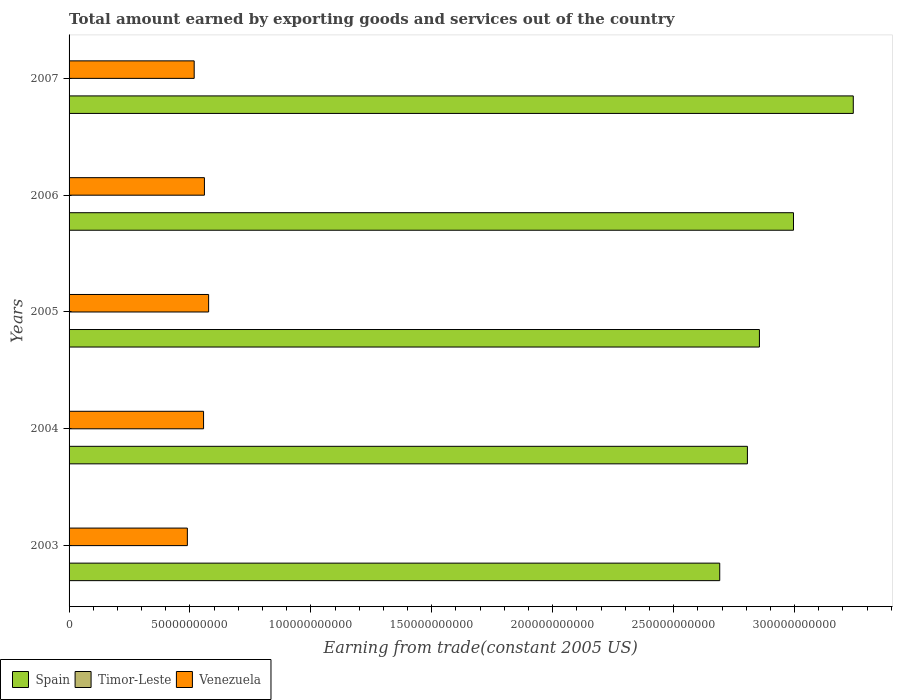How many different coloured bars are there?
Ensure brevity in your answer.  3. How many groups of bars are there?
Your response must be concise. 5. Are the number of bars per tick equal to the number of legend labels?
Provide a short and direct response. Yes. Are the number of bars on each tick of the Y-axis equal?
Your answer should be compact. Yes. How many bars are there on the 1st tick from the bottom?
Offer a terse response. 3. What is the label of the 4th group of bars from the top?
Provide a short and direct response. 2004. What is the total amount earned by exporting goods and services in Spain in 2005?
Give a very brief answer. 2.85e+11. Across all years, what is the maximum total amount earned by exporting goods and services in Venezuela?
Give a very brief answer. 5.77e+1. Across all years, what is the minimum total amount earned by exporting goods and services in Timor-Leste?
Provide a succinct answer. 4.00e+07. In which year was the total amount earned by exporting goods and services in Timor-Leste maximum?
Provide a short and direct response. 2007. In which year was the total amount earned by exporting goods and services in Timor-Leste minimum?
Give a very brief answer. 2005. What is the total total amount earned by exporting goods and services in Spain in the graph?
Offer a very short reply. 1.46e+12. What is the difference between the total amount earned by exporting goods and services in Spain in 2005 and that in 2007?
Offer a very short reply. -3.88e+1. What is the difference between the total amount earned by exporting goods and services in Timor-Leste in 2004 and the total amount earned by exporting goods and services in Venezuela in 2005?
Offer a terse response. -5.77e+1. What is the average total amount earned by exporting goods and services in Spain per year?
Offer a terse response. 2.92e+11. In the year 2007, what is the difference between the total amount earned by exporting goods and services in Venezuela and total amount earned by exporting goods and services in Spain?
Provide a succinct answer. -2.73e+11. What is the ratio of the total amount earned by exporting goods and services in Timor-Leste in 2005 to that in 2006?
Your answer should be compact. 0.98. What is the difference between the highest and the second highest total amount earned by exporting goods and services in Timor-Leste?
Offer a terse response. 1.00e+07. What is the difference between the highest and the lowest total amount earned by exporting goods and services in Venezuela?
Provide a short and direct response. 8.79e+09. In how many years, is the total amount earned by exporting goods and services in Timor-Leste greater than the average total amount earned by exporting goods and services in Timor-Leste taken over all years?
Your answer should be very brief. 1. What does the 2nd bar from the top in 2003 represents?
Ensure brevity in your answer.  Timor-Leste. How many bars are there?
Give a very brief answer. 15. Does the graph contain grids?
Offer a terse response. No. How many legend labels are there?
Make the answer very short. 3. What is the title of the graph?
Your answer should be very brief. Total amount earned by exporting goods and services out of the country. Does "Netherlands" appear as one of the legend labels in the graph?
Your answer should be very brief. No. What is the label or title of the X-axis?
Give a very brief answer. Earning from trade(constant 2005 US). What is the Earning from trade(constant 2005 US) of Spain in 2003?
Your answer should be compact. 2.69e+11. What is the Earning from trade(constant 2005 US) of Timor-Leste in 2003?
Keep it short and to the point. 4.33e+07. What is the Earning from trade(constant 2005 US) of Venezuela in 2003?
Provide a succinct answer. 4.89e+1. What is the Earning from trade(constant 2005 US) of Spain in 2004?
Your answer should be very brief. 2.81e+11. What is the Earning from trade(constant 2005 US) in Timor-Leste in 2004?
Make the answer very short. 4.25e+07. What is the Earning from trade(constant 2005 US) of Venezuela in 2004?
Make the answer very short. 5.56e+1. What is the Earning from trade(constant 2005 US) in Spain in 2005?
Give a very brief answer. 2.85e+11. What is the Earning from trade(constant 2005 US) in Timor-Leste in 2005?
Provide a succinct answer. 4.00e+07. What is the Earning from trade(constant 2005 US) of Venezuela in 2005?
Your answer should be compact. 5.77e+1. What is the Earning from trade(constant 2005 US) in Spain in 2006?
Offer a very short reply. 3.00e+11. What is the Earning from trade(constant 2005 US) in Timor-Leste in 2006?
Offer a very short reply. 4.08e+07. What is the Earning from trade(constant 2005 US) in Venezuela in 2006?
Provide a short and direct response. 5.60e+1. What is the Earning from trade(constant 2005 US) in Spain in 2007?
Offer a very short reply. 3.24e+11. What is the Earning from trade(constant 2005 US) of Timor-Leste in 2007?
Offer a terse response. 5.33e+07. What is the Earning from trade(constant 2005 US) of Venezuela in 2007?
Provide a succinct answer. 5.17e+1. Across all years, what is the maximum Earning from trade(constant 2005 US) of Spain?
Offer a terse response. 3.24e+11. Across all years, what is the maximum Earning from trade(constant 2005 US) of Timor-Leste?
Provide a succinct answer. 5.33e+07. Across all years, what is the maximum Earning from trade(constant 2005 US) in Venezuela?
Your answer should be compact. 5.77e+1. Across all years, what is the minimum Earning from trade(constant 2005 US) of Spain?
Your response must be concise. 2.69e+11. Across all years, what is the minimum Earning from trade(constant 2005 US) of Timor-Leste?
Offer a terse response. 4.00e+07. Across all years, what is the minimum Earning from trade(constant 2005 US) in Venezuela?
Offer a terse response. 4.89e+1. What is the total Earning from trade(constant 2005 US) in Spain in the graph?
Make the answer very short. 1.46e+12. What is the total Earning from trade(constant 2005 US) in Timor-Leste in the graph?
Ensure brevity in your answer.  2.20e+08. What is the total Earning from trade(constant 2005 US) of Venezuela in the graph?
Offer a very short reply. 2.70e+11. What is the difference between the Earning from trade(constant 2005 US) in Spain in 2003 and that in 2004?
Offer a terse response. -1.14e+1. What is the difference between the Earning from trade(constant 2005 US) of Timor-Leste in 2003 and that in 2004?
Make the answer very short. 8.33e+05. What is the difference between the Earning from trade(constant 2005 US) of Venezuela in 2003 and that in 2004?
Ensure brevity in your answer.  -6.69e+09. What is the difference between the Earning from trade(constant 2005 US) of Spain in 2003 and that in 2005?
Give a very brief answer. -1.64e+1. What is the difference between the Earning from trade(constant 2005 US) of Timor-Leste in 2003 and that in 2005?
Offer a terse response. 3.33e+06. What is the difference between the Earning from trade(constant 2005 US) of Venezuela in 2003 and that in 2005?
Your answer should be very brief. -8.79e+09. What is the difference between the Earning from trade(constant 2005 US) in Spain in 2003 and that in 2006?
Your answer should be very brief. -3.05e+1. What is the difference between the Earning from trade(constant 2005 US) in Timor-Leste in 2003 and that in 2006?
Your answer should be very brief. 2.50e+06. What is the difference between the Earning from trade(constant 2005 US) in Venezuela in 2003 and that in 2006?
Provide a succinct answer. -7.05e+09. What is the difference between the Earning from trade(constant 2005 US) in Spain in 2003 and that in 2007?
Your response must be concise. -5.52e+1. What is the difference between the Earning from trade(constant 2005 US) in Timor-Leste in 2003 and that in 2007?
Offer a terse response. -1.00e+07. What is the difference between the Earning from trade(constant 2005 US) in Venezuela in 2003 and that in 2007?
Your answer should be very brief. -2.82e+09. What is the difference between the Earning from trade(constant 2005 US) of Spain in 2004 and that in 2005?
Offer a very short reply. -4.97e+09. What is the difference between the Earning from trade(constant 2005 US) in Timor-Leste in 2004 and that in 2005?
Provide a short and direct response. 2.50e+06. What is the difference between the Earning from trade(constant 2005 US) of Venezuela in 2004 and that in 2005?
Provide a succinct answer. -2.10e+09. What is the difference between the Earning from trade(constant 2005 US) of Spain in 2004 and that in 2006?
Offer a very short reply. -1.91e+1. What is the difference between the Earning from trade(constant 2005 US) of Timor-Leste in 2004 and that in 2006?
Give a very brief answer. 1.67e+06. What is the difference between the Earning from trade(constant 2005 US) in Venezuela in 2004 and that in 2006?
Keep it short and to the point. -3.55e+08. What is the difference between the Earning from trade(constant 2005 US) in Spain in 2004 and that in 2007?
Provide a succinct answer. -4.38e+1. What is the difference between the Earning from trade(constant 2005 US) of Timor-Leste in 2004 and that in 2007?
Provide a succinct answer. -1.08e+07. What is the difference between the Earning from trade(constant 2005 US) in Venezuela in 2004 and that in 2007?
Provide a succinct answer. 3.87e+09. What is the difference between the Earning from trade(constant 2005 US) of Spain in 2005 and that in 2006?
Your answer should be very brief. -1.41e+1. What is the difference between the Earning from trade(constant 2005 US) of Timor-Leste in 2005 and that in 2006?
Your answer should be very brief. -8.33e+05. What is the difference between the Earning from trade(constant 2005 US) of Venezuela in 2005 and that in 2006?
Ensure brevity in your answer.  1.74e+09. What is the difference between the Earning from trade(constant 2005 US) in Spain in 2005 and that in 2007?
Provide a short and direct response. -3.88e+1. What is the difference between the Earning from trade(constant 2005 US) of Timor-Leste in 2005 and that in 2007?
Provide a short and direct response. -1.33e+07. What is the difference between the Earning from trade(constant 2005 US) in Venezuela in 2005 and that in 2007?
Offer a very short reply. 5.97e+09. What is the difference between the Earning from trade(constant 2005 US) of Spain in 2006 and that in 2007?
Offer a terse response. -2.47e+1. What is the difference between the Earning from trade(constant 2005 US) of Timor-Leste in 2006 and that in 2007?
Your answer should be very brief. -1.25e+07. What is the difference between the Earning from trade(constant 2005 US) in Venezuela in 2006 and that in 2007?
Provide a short and direct response. 4.23e+09. What is the difference between the Earning from trade(constant 2005 US) in Spain in 2003 and the Earning from trade(constant 2005 US) in Timor-Leste in 2004?
Offer a very short reply. 2.69e+11. What is the difference between the Earning from trade(constant 2005 US) in Spain in 2003 and the Earning from trade(constant 2005 US) in Venezuela in 2004?
Provide a succinct answer. 2.13e+11. What is the difference between the Earning from trade(constant 2005 US) of Timor-Leste in 2003 and the Earning from trade(constant 2005 US) of Venezuela in 2004?
Provide a succinct answer. -5.56e+1. What is the difference between the Earning from trade(constant 2005 US) of Spain in 2003 and the Earning from trade(constant 2005 US) of Timor-Leste in 2005?
Your response must be concise. 2.69e+11. What is the difference between the Earning from trade(constant 2005 US) of Spain in 2003 and the Earning from trade(constant 2005 US) of Venezuela in 2005?
Ensure brevity in your answer.  2.11e+11. What is the difference between the Earning from trade(constant 2005 US) in Timor-Leste in 2003 and the Earning from trade(constant 2005 US) in Venezuela in 2005?
Offer a terse response. -5.77e+1. What is the difference between the Earning from trade(constant 2005 US) of Spain in 2003 and the Earning from trade(constant 2005 US) of Timor-Leste in 2006?
Provide a succinct answer. 2.69e+11. What is the difference between the Earning from trade(constant 2005 US) of Spain in 2003 and the Earning from trade(constant 2005 US) of Venezuela in 2006?
Provide a short and direct response. 2.13e+11. What is the difference between the Earning from trade(constant 2005 US) of Timor-Leste in 2003 and the Earning from trade(constant 2005 US) of Venezuela in 2006?
Your response must be concise. -5.59e+1. What is the difference between the Earning from trade(constant 2005 US) in Spain in 2003 and the Earning from trade(constant 2005 US) in Timor-Leste in 2007?
Your answer should be compact. 2.69e+11. What is the difference between the Earning from trade(constant 2005 US) in Spain in 2003 and the Earning from trade(constant 2005 US) in Venezuela in 2007?
Offer a terse response. 2.17e+11. What is the difference between the Earning from trade(constant 2005 US) in Timor-Leste in 2003 and the Earning from trade(constant 2005 US) in Venezuela in 2007?
Your answer should be very brief. -5.17e+1. What is the difference between the Earning from trade(constant 2005 US) in Spain in 2004 and the Earning from trade(constant 2005 US) in Timor-Leste in 2005?
Offer a very short reply. 2.80e+11. What is the difference between the Earning from trade(constant 2005 US) of Spain in 2004 and the Earning from trade(constant 2005 US) of Venezuela in 2005?
Your response must be concise. 2.23e+11. What is the difference between the Earning from trade(constant 2005 US) in Timor-Leste in 2004 and the Earning from trade(constant 2005 US) in Venezuela in 2005?
Provide a short and direct response. -5.77e+1. What is the difference between the Earning from trade(constant 2005 US) in Spain in 2004 and the Earning from trade(constant 2005 US) in Timor-Leste in 2006?
Give a very brief answer. 2.80e+11. What is the difference between the Earning from trade(constant 2005 US) in Spain in 2004 and the Earning from trade(constant 2005 US) in Venezuela in 2006?
Your response must be concise. 2.25e+11. What is the difference between the Earning from trade(constant 2005 US) in Timor-Leste in 2004 and the Earning from trade(constant 2005 US) in Venezuela in 2006?
Provide a short and direct response. -5.59e+1. What is the difference between the Earning from trade(constant 2005 US) in Spain in 2004 and the Earning from trade(constant 2005 US) in Timor-Leste in 2007?
Make the answer very short. 2.80e+11. What is the difference between the Earning from trade(constant 2005 US) of Spain in 2004 and the Earning from trade(constant 2005 US) of Venezuela in 2007?
Offer a terse response. 2.29e+11. What is the difference between the Earning from trade(constant 2005 US) of Timor-Leste in 2004 and the Earning from trade(constant 2005 US) of Venezuela in 2007?
Your answer should be very brief. -5.17e+1. What is the difference between the Earning from trade(constant 2005 US) in Spain in 2005 and the Earning from trade(constant 2005 US) in Timor-Leste in 2006?
Make the answer very short. 2.85e+11. What is the difference between the Earning from trade(constant 2005 US) of Spain in 2005 and the Earning from trade(constant 2005 US) of Venezuela in 2006?
Keep it short and to the point. 2.30e+11. What is the difference between the Earning from trade(constant 2005 US) in Timor-Leste in 2005 and the Earning from trade(constant 2005 US) in Venezuela in 2006?
Your answer should be very brief. -5.59e+1. What is the difference between the Earning from trade(constant 2005 US) in Spain in 2005 and the Earning from trade(constant 2005 US) in Timor-Leste in 2007?
Ensure brevity in your answer.  2.85e+11. What is the difference between the Earning from trade(constant 2005 US) of Spain in 2005 and the Earning from trade(constant 2005 US) of Venezuela in 2007?
Offer a terse response. 2.34e+11. What is the difference between the Earning from trade(constant 2005 US) in Timor-Leste in 2005 and the Earning from trade(constant 2005 US) in Venezuela in 2007?
Give a very brief answer. -5.17e+1. What is the difference between the Earning from trade(constant 2005 US) of Spain in 2006 and the Earning from trade(constant 2005 US) of Timor-Leste in 2007?
Offer a very short reply. 3.00e+11. What is the difference between the Earning from trade(constant 2005 US) of Spain in 2006 and the Earning from trade(constant 2005 US) of Venezuela in 2007?
Your answer should be compact. 2.48e+11. What is the difference between the Earning from trade(constant 2005 US) in Timor-Leste in 2006 and the Earning from trade(constant 2005 US) in Venezuela in 2007?
Ensure brevity in your answer.  -5.17e+1. What is the average Earning from trade(constant 2005 US) of Spain per year?
Your answer should be compact. 2.92e+11. What is the average Earning from trade(constant 2005 US) of Timor-Leste per year?
Provide a succinct answer. 4.40e+07. What is the average Earning from trade(constant 2005 US) in Venezuela per year?
Offer a terse response. 5.40e+1. In the year 2003, what is the difference between the Earning from trade(constant 2005 US) in Spain and Earning from trade(constant 2005 US) in Timor-Leste?
Keep it short and to the point. 2.69e+11. In the year 2003, what is the difference between the Earning from trade(constant 2005 US) of Spain and Earning from trade(constant 2005 US) of Venezuela?
Your answer should be very brief. 2.20e+11. In the year 2003, what is the difference between the Earning from trade(constant 2005 US) of Timor-Leste and Earning from trade(constant 2005 US) of Venezuela?
Offer a terse response. -4.89e+1. In the year 2004, what is the difference between the Earning from trade(constant 2005 US) in Spain and Earning from trade(constant 2005 US) in Timor-Leste?
Offer a very short reply. 2.80e+11. In the year 2004, what is the difference between the Earning from trade(constant 2005 US) in Spain and Earning from trade(constant 2005 US) in Venezuela?
Your answer should be compact. 2.25e+11. In the year 2004, what is the difference between the Earning from trade(constant 2005 US) in Timor-Leste and Earning from trade(constant 2005 US) in Venezuela?
Offer a very short reply. -5.56e+1. In the year 2005, what is the difference between the Earning from trade(constant 2005 US) of Spain and Earning from trade(constant 2005 US) of Timor-Leste?
Offer a terse response. 2.85e+11. In the year 2005, what is the difference between the Earning from trade(constant 2005 US) in Spain and Earning from trade(constant 2005 US) in Venezuela?
Give a very brief answer. 2.28e+11. In the year 2005, what is the difference between the Earning from trade(constant 2005 US) of Timor-Leste and Earning from trade(constant 2005 US) of Venezuela?
Keep it short and to the point. -5.77e+1. In the year 2006, what is the difference between the Earning from trade(constant 2005 US) of Spain and Earning from trade(constant 2005 US) of Timor-Leste?
Offer a very short reply. 3.00e+11. In the year 2006, what is the difference between the Earning from trade(constant 2005 US) of Spain and Earning from trade(constant 2005 US) of Venezuela?
Make the answer very short. 2.44e+11. In the year 2006, what is the difference between the Earning from trade(constant 2005 US) in Timor-Leste and Earning from trade(constant 2005 US) in Venezuela?
Give a very brief answer. -5.59e+1. In the year 2007, what is the difference between the Earning from trade(constant 2005 US) in Spain and Earning from trade(constant 2005 US) in Timor-Leste?
Offer a terse response. 3.24e+11. In the year 2007, what is the difference between the Earning from trade(constant 2005 US) of Spain and Earning from trade(constant 2005 US) of Venezuela?
Your response must be concise. 2.73e+11. In the year 2007, what is the difference between the Earning from trade(constant 2005 US) of Timor-Leste and Earning from trade(constant 2005 US) of Venezuela?
Your answer should be very brief. -5.17e+1. What is the ratio of the Earning from trade(constant 2005 US) in Spain in 2003 to that in 2004?
Keep it short and to the point. 0.96. What is the ratio of the Earning from trade(constant 2005 US) of Timor-Leste in 2003 to that in 2004?
Your response must be concise. 1.02. What is the ratio of the Earning from trade(constant 2005 US) in Venezuela in 2003 to that in 2004?
Give a very brief answer. 0.88. What is the ratio of the Earning from trade(constant 2005 US) in Spain in 2003 to that in 2005?
Offer a terse response. 0.94. What is the ratio of the Earning from trade(constant 2005 US) of Timor-Leste in 2003 to that in 2005?
Your response must be concise. 1.08. What is the ratio of the Earning from trade(constant 2005 US) of Venezuela in 2003 to that in 2005?
Provide a succinct answer. 0.85. What is the ratio of the Earning from trade(constant 2005 US) in Spain in 2003 to that in 2006?
Keep it short and to the point. 0.9. What is the ratio of the Earning from trade(constant 2005 US) of Timor-Leste in 2003 to that in 2006?
Make the answer very short. 1.06. What is the ratio of the Earning from trade(constant 2005 US) of Venezuela in 2003 to that in 2006?
Your answer should be very brief. 0.87. What is the ratio of the Earning from trade(constant 2005 US) in Spain in 2003 to that in 2007?
Keep it short and to the point. 0.83. What is the ratio of the Earning from trade(constant 2005 US) in Timor-Leste in 2003 to that in 2007?
Your response must be concise. 0.81. What is the ratio of the Earning from trade(constant 2005 US) in Venezuela in 2003 to that in 2007?
Make the answer very short. 0.95. What is the ratio of the Earning from trade(constant 2005 US) of Spain in 2004 to that in 2005?
Provide a succinct answer. 0.98. What is the ratio of the Earning from trade(constant 2005 US) of Timor-Leste in 2004 to that in 2005?
Make the answer very short. 1.06. What is the ratio of the Earning from trade(constant 2005 US) of Venezuela in 2004 to that in 2005?
Your answer should be very brief. 0.96. What is the ratio of the Earning from trade(constant 2005 US) in Spain in 2004 to that in 2006?
Make the answer very short. 0.94. What is the ratio of the Earning from trade(constant 2005 US) of Timor-Leste in 2004 to that in 2006?
Make the answer very short. 1.04. What is the ratio of the Earning from trade(constant 2005 US) of Venezuela in 2004 to that in 2006?
Your response must be concise. 0.99. What is the ratio of the Earning from trade(constant 2005 US) of Spain in 2004 to that in 2007?
Make the answer very short. 0.86. What is the ratio of the Earning from trade(constant 2005 US) in Timor-Leste in 2004 to that in 2007?
Offer a terse response. 0.8. What is the ratio of the Earning from trade(constant 2005 US) in Venezuela in 2004 to that in 2007?
Provide a short and direct response. 1.07. What is the ratio of the Earning from trade(constant 2005 US) of Spain in 2005 to that in 2006?
Provide a short and direct response. 0.95. What is the ratio of the Earning from trade(constant 2005 US) in Timor-Leste in 2005 to that in 2006?
Provide a short and direct response. 0.98. What is the ratio of the Earning from trade(constant 2005 US) in Venezuela in 2005 to that in 2006?
Provide a succinct answer. 1.03. What is the ratio of the Earning from trade(constant 2005 US) in Spain in 2005 to that in 2007?
Offer a very short reply. 0.88. What is the ratio of the Earning from trade(constant 2005 US) of Venezuela in 2005 to that in 2007?
Make the answer very short. 1.12. What is the ratio of the Earning from trade(constant 2005 US) in Spain in 2006 to that in 2007?
Offer a very short reply. 0.92. What is the ratio of the Earning from trade(constant 2005 US) in Timor-Leste in 2006 to that in 2007?
Make the answer very short. 0.77. What is the ratio of the Earning from trade(constant 2005 US) of Venezuela in 2006 to that in 2007?
Keep it short and to the point. 1.08. What is the difference between the highest and the second highest Earning from trade(constant 2005 US) in Spain?
Make the answer very short. 2.47e+1. What is the difference between the highest and the second highest Earning from trade(constant 2005 US) in Venezuela?
Provide a succinct answer. 1.74e+09. What is the difference between the highest and the lowest Earning from trade(constant 2005 US) of Spain?
Ensure brevity in your answer.  5.52e+1. What is the difference between the highest and the lowest Earning from trade(constant 2005 US) of Timor-Leste?
Give a very brief answer. 1.33e+07. What is the difference between the highest and the lowest Earning from trade(constant 2005 US) of Venezuela?
Your answer should be compact. 8.79e+09. 